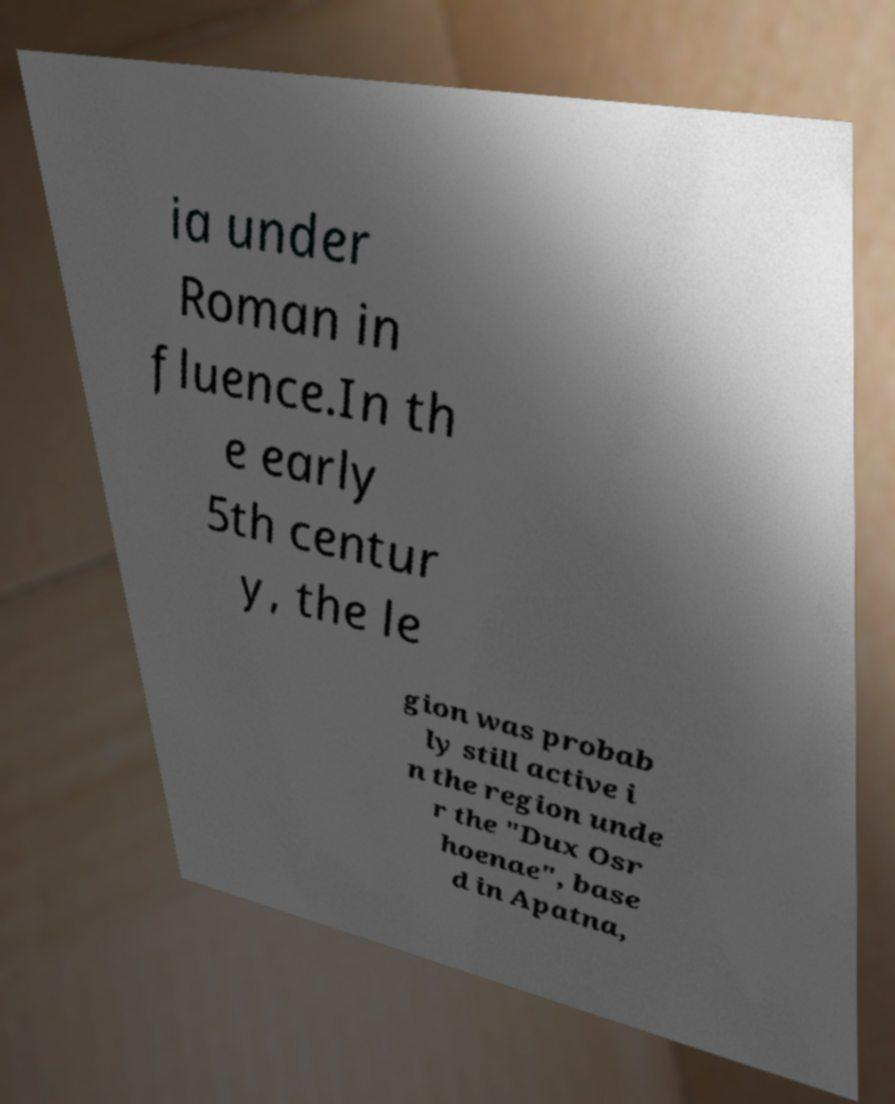I need the written content from this picture converted into text. Can you do that? ia under Roman in fluence.In th e early 5th centur y, the le gion was probab ly still active i n the region unde r the "Dux Osr hoenae", base d in Apatna, 